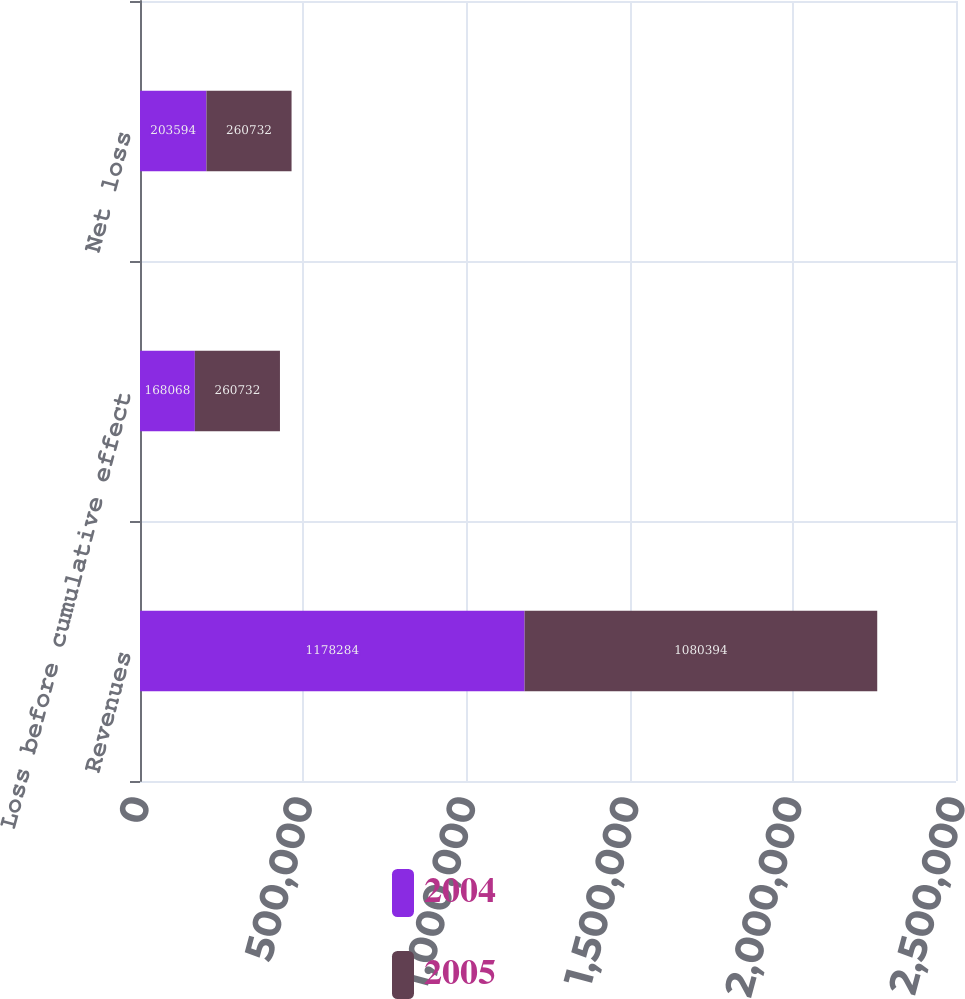Convert chart. <chart><loc_0><loc_0><loc_500><loc_500><stacked_bar_chart><ecel><fcel>Revenues<fcel>Loss before cumulative effect<fcel>Net loss<nl><fcel>2004<fcel>1.17828e+06<fcel>168068<fcel>203594<nl><fcel>2005<fcel>1.08039e+06<fcel>260732<fcel>260732<nl></chart> 